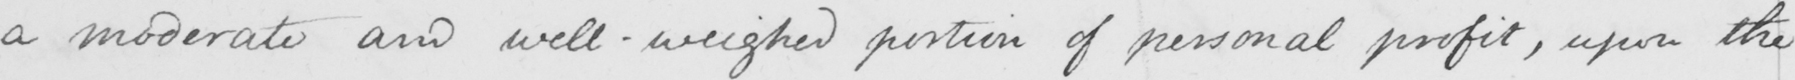Please provide the text content of this handwritten line. a moderate and well-weighed portion of personal profit , upon the 